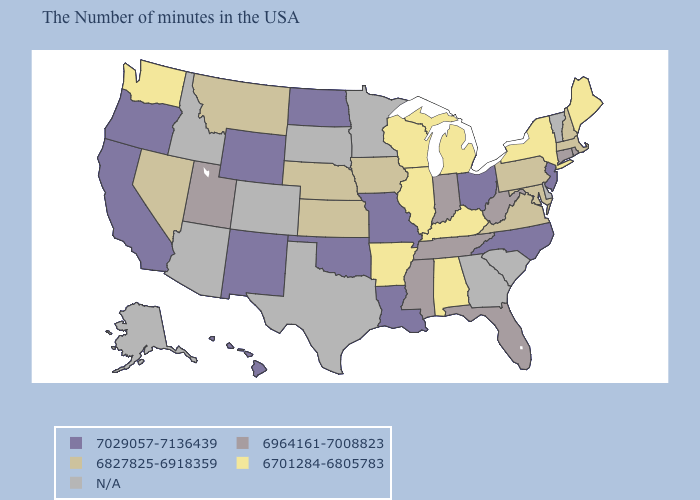Does the first symbol in the legend represent the smallest category?
Answer briefly. No. Does the map have missing data?
Give a very brief answer. Yes. What is the highest value in states that border Ohio?
Concise answer only. 6964161-7008823. Which states have the lowest value in the USA?
Write a very short answer. Maine, New York, Michigan, Kentucky, Alabama, Wisconsin, Illinois, Arkansas, Washington. Name the states that have a value in the range 6827825-6918359?
Short answer required. Massachusetts, New Hampshire, Maryland, Pennsylvania, Virginia, Iowa, Kansas, Nebraska, Montana, Nevada. What is the highest value in the Northeast ?
Be succinct. 7029057-7136439. Name the states that have a value in the range 7029057-7136439?
Quick response, please. New Jersey, North Carolina, Ohio, Louisiana, Missouri, Oklahoma, North Dakota, Wyoming, New Mexico, California, Oregon, Hawaii. Does Arkansas have the lowest value in the USA?
Answer briefly. Yes. What is the highest value in the West ?
Keep it brief. 7029057-7136439. What is the highest value in states that border Virginia?
Write a very short answer. 7029057-7136439. What is the highest value in the USA?
Short answer required. 7029057-7136439. What is the lowest value in the Northeast?
Answer briefly. 6701284-6805783. Among the states that border Georgia , which have the highest value?
Quick response, please. North Carolina. What is the lowest value in the MidWest?
Concise answer only. 6701284-6805783. What is the value of Rhode Island?
Be succinct. 6964161-7008823. 